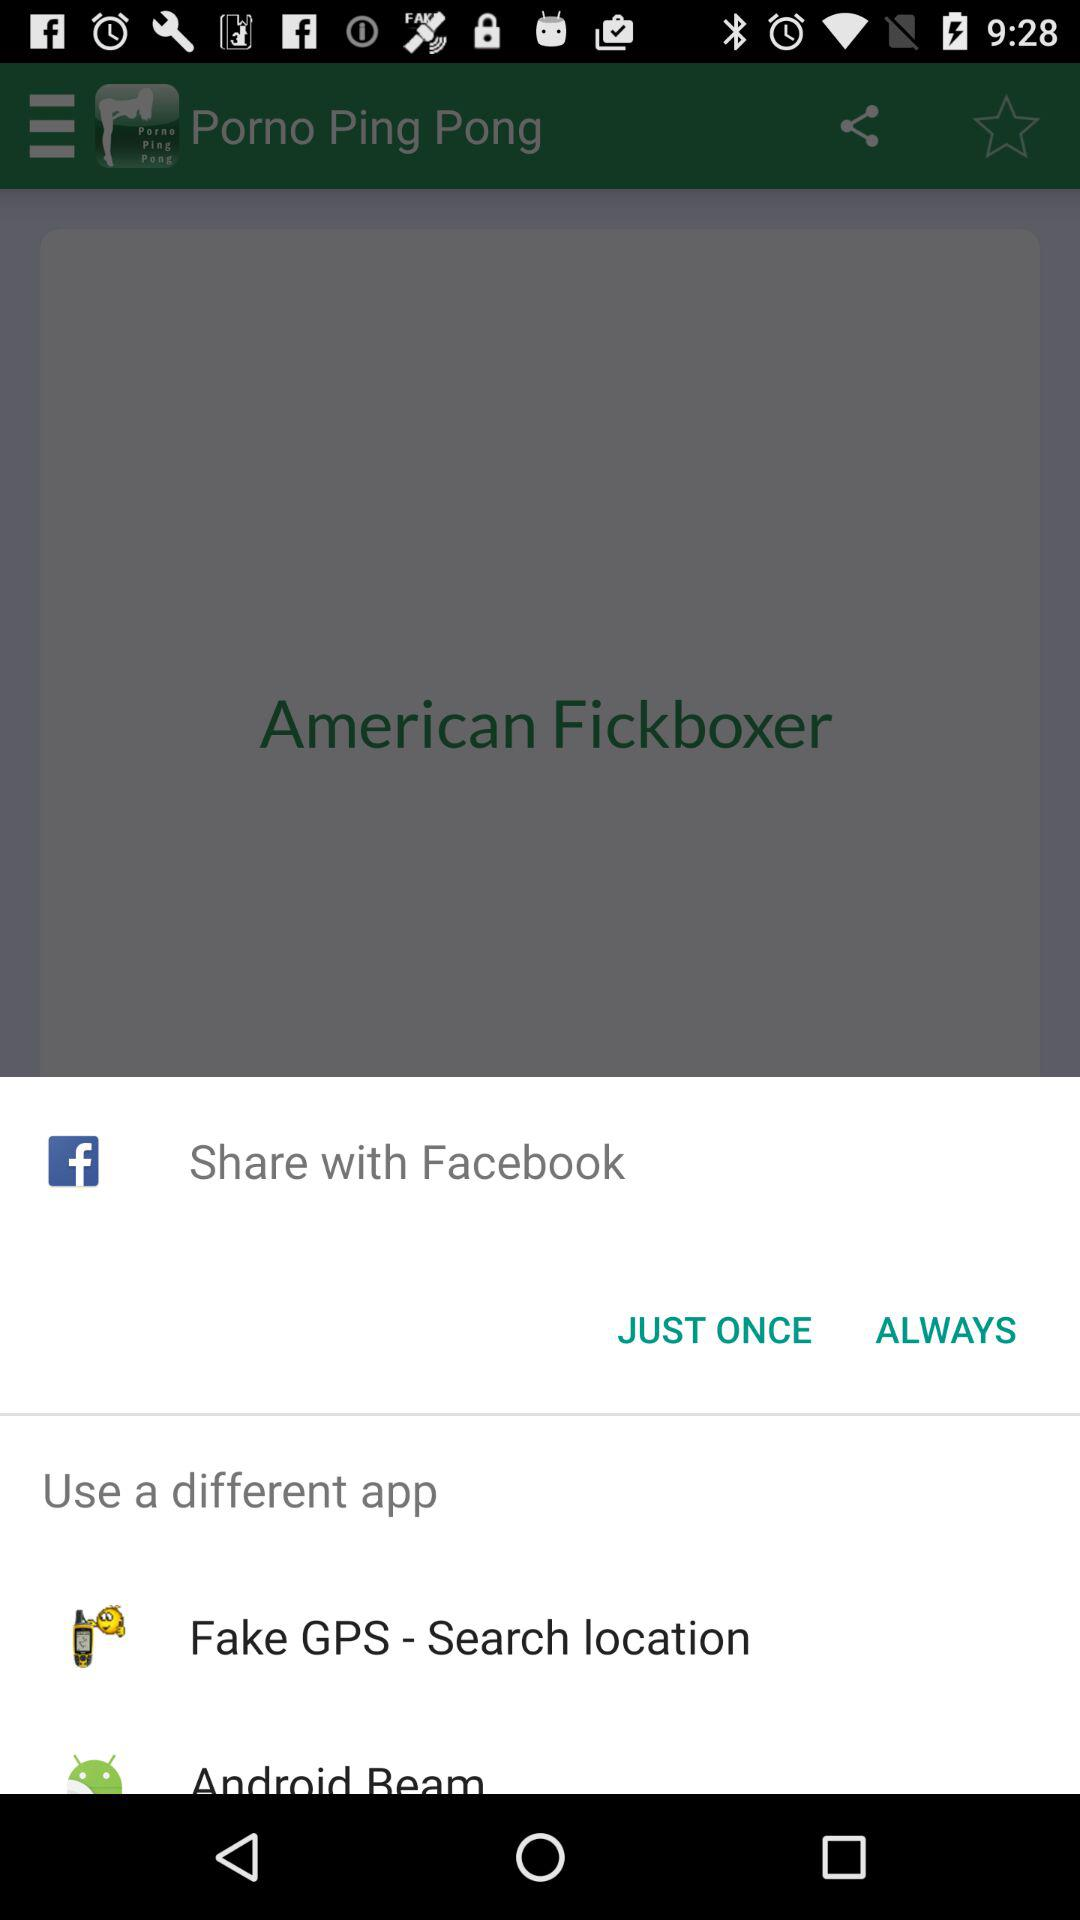What is the name of the application? The name of the application is "Porno Ping Pong". 